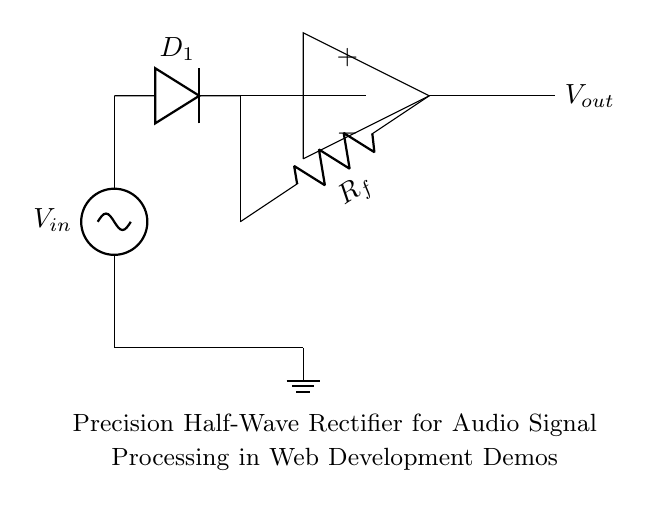What is the input voltage in the circuit? The input voltage is labeled as V_in, which is the source of the AC signal for the rectifier.
Answer: V_in What type of diode is used in this rectifier circuit? The circuit uses a generic diode labeled D_1, which allows current to flow in one direction only, critical for rectification.
Answer: D_1 What is the output voltage of the circuit? The output voltage is labeled as V_out, indicating the processed voltage after rectification. The exact value isn't specified, just that it is the output of the precision half-wave rectifier.
Answer: V_out What is the role of the feedback resistor? The feedback resistor R_f is used in the operational amplifier circuit to stabilize the output and set the gain of the rectifier, ensuring precision in signal processing.
Answer: Stabilization How does this circuit process negative inputs? The precision half-wave rectifier allows for only the positive half of the input signal to pass through, effectively processing negative inputs by outputting zero during those times.
Answer: Outputs zero What is the significance of the operational amplifier in this rectifier? The operational amplifier is crucial for improving the precision of the rectification by providing high input impedance and allowing for better signal integrity when processing audio signals.
Answer: High precision 